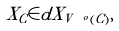Convert formula to latex. <formula><loc_0><loc_0><loc_500><loc_500>X _ { C } \in d X _ { V \ ^ { o } ( C ) } ,</formula> 